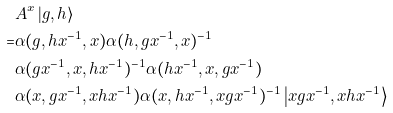Convert formula to latex. <formula><loc_0><loc_0><loc_500><loc_500>& A ^ { x } \left | g , h \right \rangle \\ = & \alpha ( g , h x ^ { - 1 } , x ) \alpha ( h , g x ^ { - 1 } , x ) ^ { - 1 } \\ & \alpha ( g x ^ { - 1 } , x , h x ^ { - 1 } ) ^ { - 1 } \alpha ( h x ^ { - 1 } , x , g x ^ { - 1 } ) \\ & \alpha ( x , g x ^ { - 1 } , x h x ^ { - 1 } ) \alpha ( x , h x ^ { - 1 } , x g x ^ { - 1 } ) ^ { - 1 } \left | x g x ^ { - 1 } , x h x ^ { - 1 } \right \rangle</formula> 